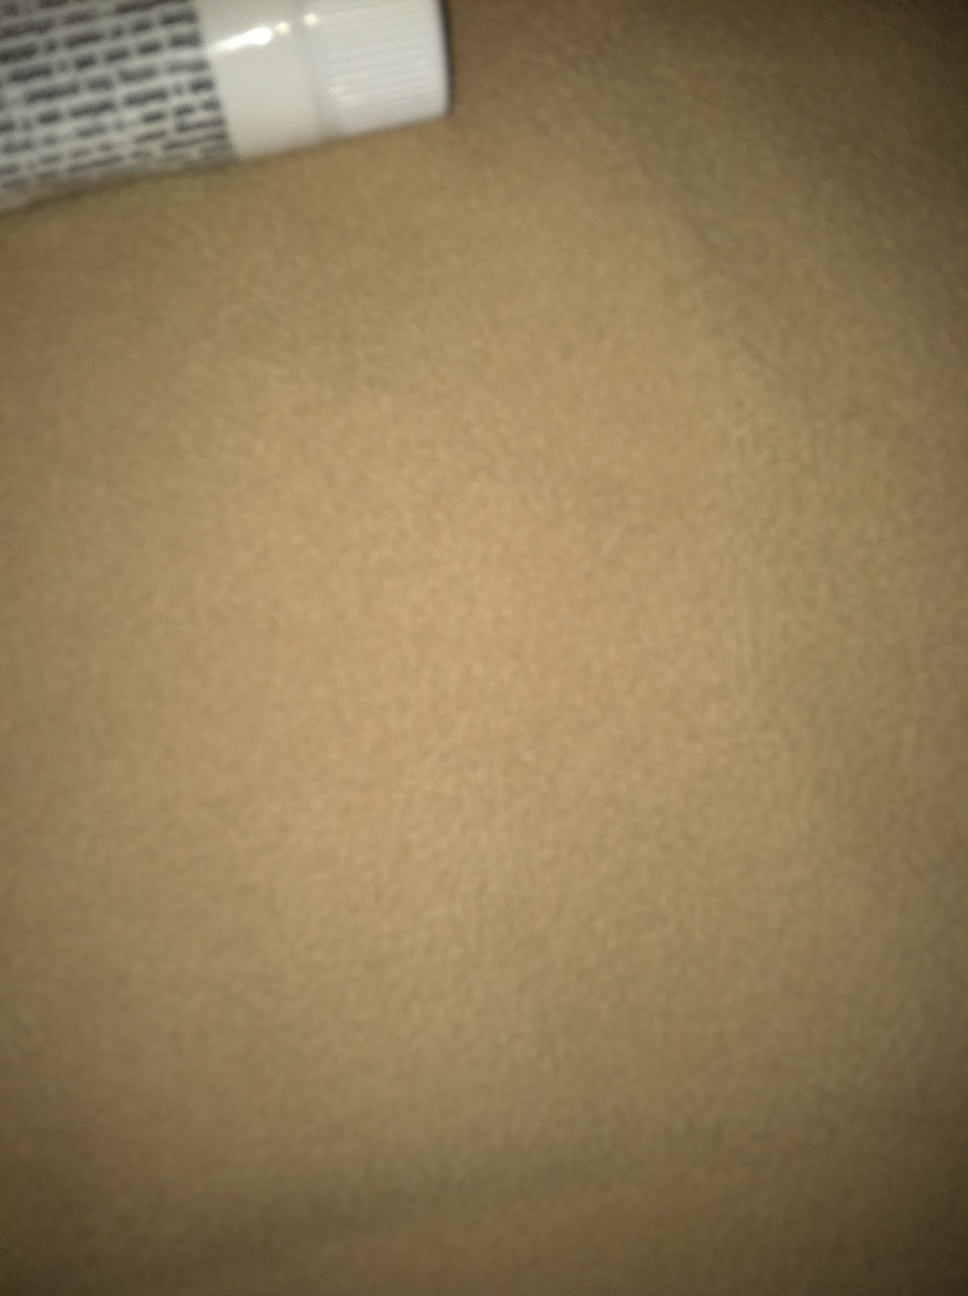Do you have any advice on how to best capture the product for identification? For better product identification, take a picture with good lighting and make sure the entire product is in the frame. Focus on any text, logos, or distinctive features of the item. A clear, high-resolution image can significantly improve the accuracy of product identification. What details should I look for on packaging that can be informative? Look for the product name, brand name, list of ingredients, any specific claims or uses mentioned, barcodes, QR codes, or any certifications or symbols that indicate quality standards, to name a few details that could be informative. 